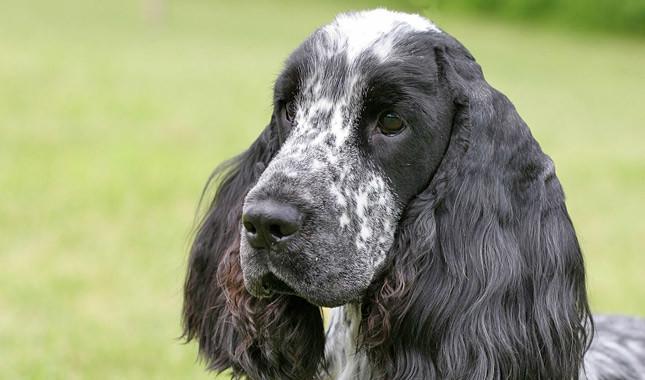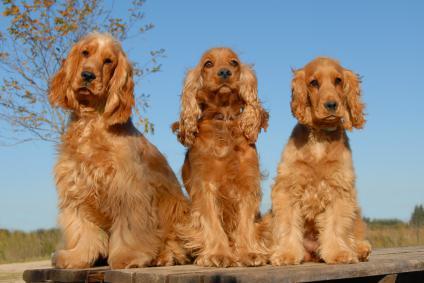The first image is the image on the left, the second image is the image on the right. For the images shown, is this caption "Right image shows at least one golden-haired dog sitting upright." true? Answer yes or no. Yes. The first image is the image on the left, the second image is the image on the right. For the images shown, is this caption "The brown dogs in the image on the right are sitting outside." true? Answer yes or no. Yes. 